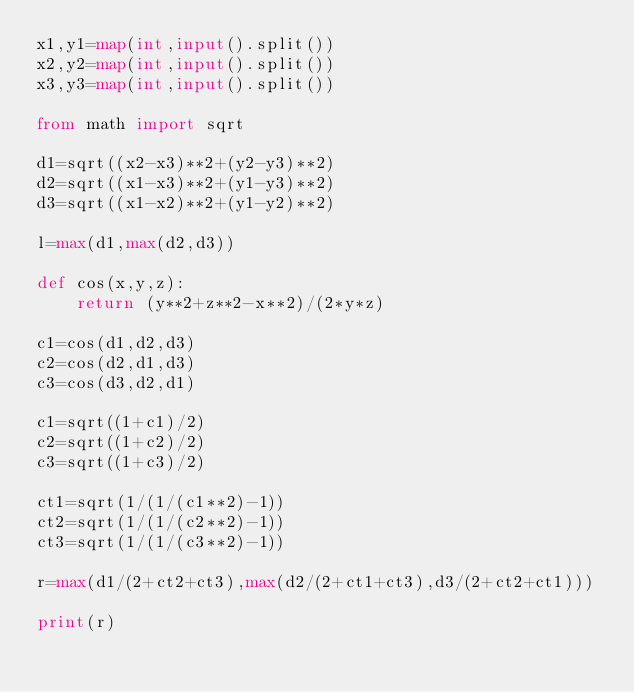Convert code to text. <code><loc_0><loc_0><loc_500><loc_500><_Python_>x1,y1=map(int,input().split())
x2,y2=map(int,input().split())
x3,y3=map(int,input().split())

from math import sqrt

d1=sqrt((x2-x3)**2+(y2-y3)**2)
d2=sqrt((x1-x3)**2+(y1-y3)**2)
d3=sqrt((x1-x2)**2+(y1-y2)**2)

l=max(d1,max(d2,d3))

def cos(x,y,z):
    return (y**2+z**2-x**2)/(2*y*z)

c1=cos(d1,d2,d3)
c2=cos(d2,d1,d3)
c3=cos(d3,d2,d1)

c1=sqrt((1+c1)/2)
c2=sqrt((1+c2)/2)
c3=sqrt((1+c3)/2)

ct1=sqrt(1/(1/(c1**2)-1))
ct2=sqrt(1/(1/(c2**2)-1))
ct3=sqrt(1/(1/(c3**2)-1))

r=max(d1/(2+ct2+ct3),max(d2/(2+ct1+ct3),d3/(2+ct2+ct1)))

print(r)
</code> 